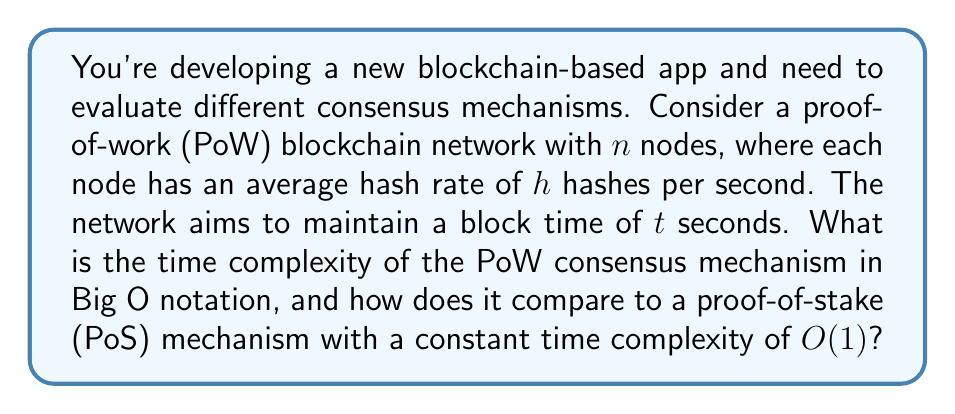Provide a solution to this math problem. To analyze the time complexity of the PoW consensus mechanism, we need to consider the following steps:

1. In a PoW system, nodes compete to solve a cryptographic puzzle. The difficulty of this puzzle is adjusted to maintain the target block time $t$.

2. The probability of finding a solution in a single hash attempt is $\frac{1}{D}$, where $D$ is the current difficulty.

3. With $n$ nodes, each with hash rate $h$, the total network hash rate is $n \cdot h$ hashes per second.

4. To maintain the target block time $t$, we need:

   $$(n \cdot h) \cdot t \cdot \frac{1}{D} = 1$$

5. Solving for $D$:

   $$D = n \cdot h \cdot t$$

6. The expected number of hashes needed to find a solution is equal to $D$.

7. Therefore, the time complexity for a single node to find a solution is $O(D) = O(n \cdot h \cdot t)$.

8. Since $h$ and $t$ are constants in this scenario, we can simplify to $O(n)$.

Comparing to PoS:
- PoW: $O(n)$
- PoS: $O(1)$

As the number of nodes ($n$) increases, the PoW mechanism becomes less efficient, while PoS maintains constant time complexity regardless of network size.
Answer: The time complexity of the PoW consensus mechanism is $O(n)$, where $n$ is the number of nodes in the network. This is less efficient than the PoS mechanism, which has a constant time complexity of $O(1)$. 